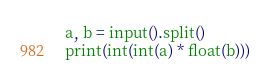<code> <loc_0><loc_0><loc_500><loc_500><_Python_>a, b = input().split()
print(int(int(a) * float(b)))</code> 